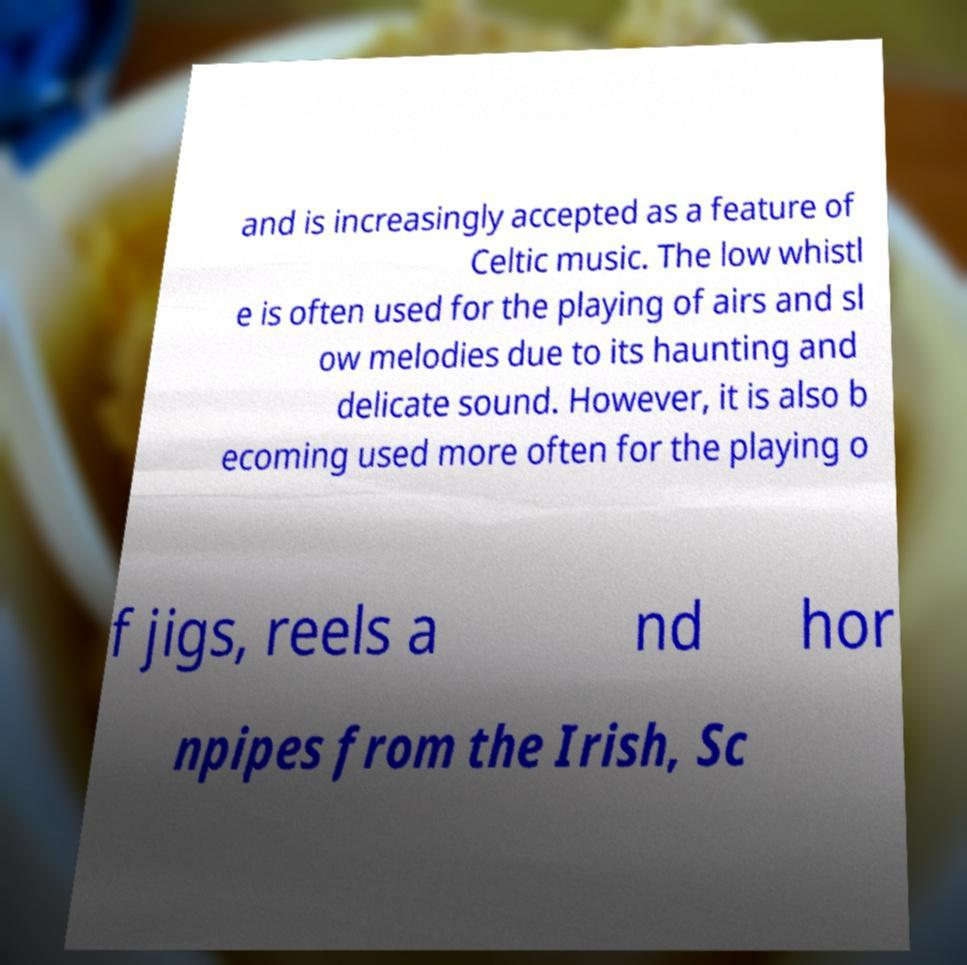Please read and relay the text visible in this image. What does it say? and is increasingly accepted as a feature of Celtic music. The low whistl e is often used for the playing of airs and sl ow melodies due to its haunting and delicate sound. However, it is also b ecoming used more often for the playing o f jigs, reels a nd hor npipes from the Irish, Sc 